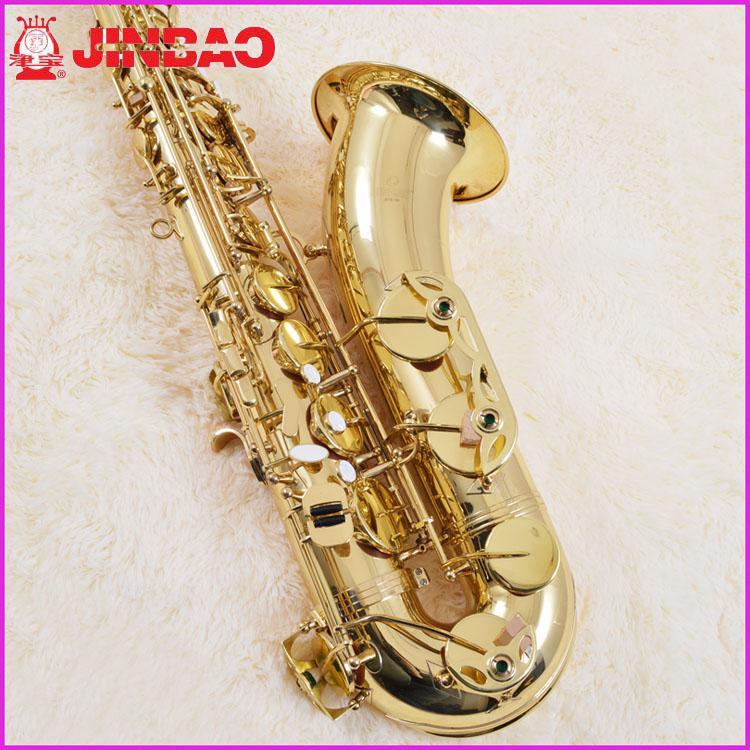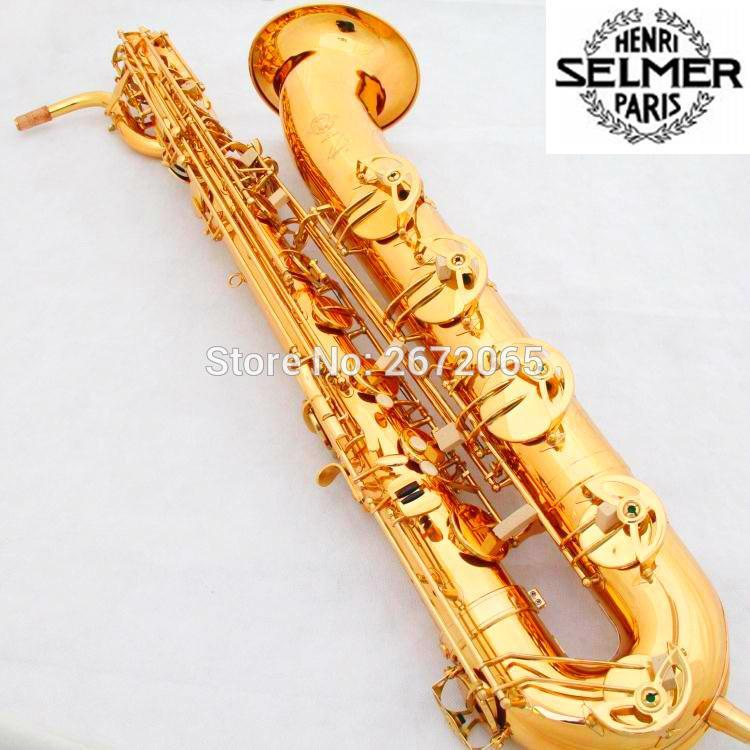The first image is the image on the left, the second image is the image on the right. Given the left and right images, does the statement "An image shows a right-facing saxophone displayed vertically." hold true? Answer yes or no. No. The first image is the image on the left, the second image is the image on the right. For the images shown, is this caption "The entire saxophone is visible in each image." true? Answer yes or no. No. 